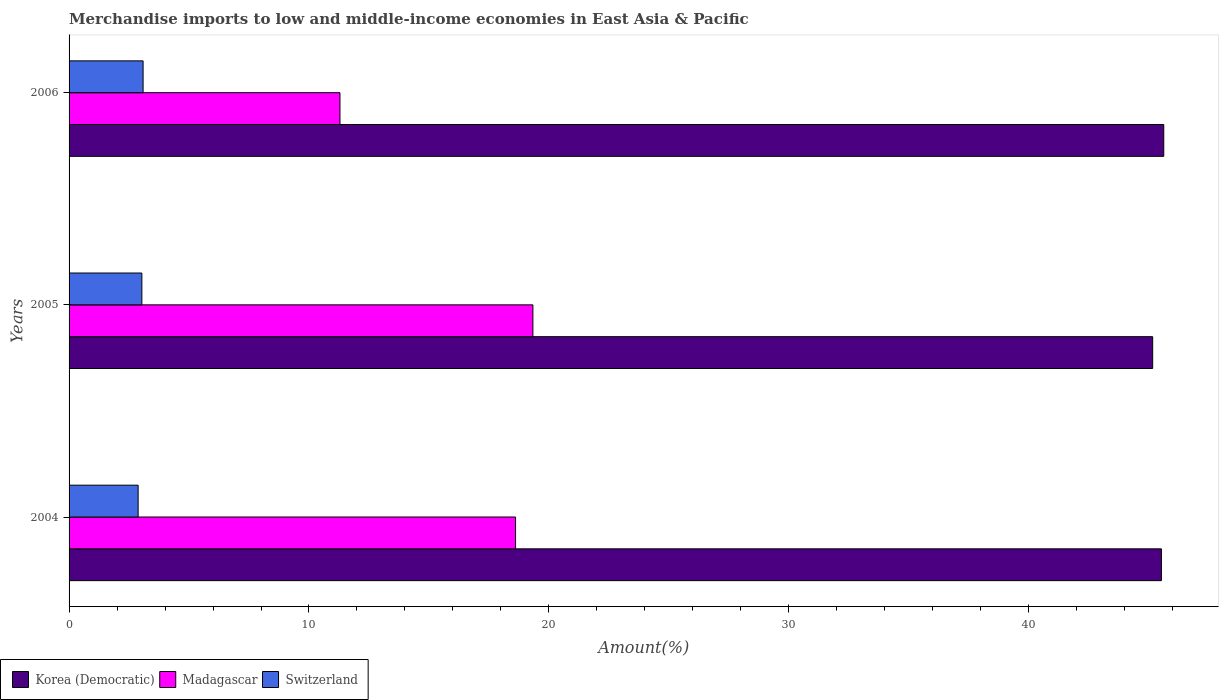How many different coloured bars are there?
Provide a succinct answer. 3. How many groups of bars are there?
Give a very brief answer. 3. Are the number of bars on each tick of the Y-axis equal?
Your answer should be very brief. Yes. How many bars are there on the 2nd tick from the bottom?
Give a very brief answer. 3. In how many cases, is the number of bars for a given year not equal to the number of legend labels?
Offer a terse response. 0. What is the percentage of amount earned from merchandise imports in Switzerland in 2006?
Offer a terse response. 3.09. Across all years, what is the maximum percentage of amount earned from merchandise imports in Switzerland?
Make the answer very short. 3.09. Across all years, what is the minimum percentage of amount earned from merchandise imports in Switzerland?
Give a very brief answer. 2.88. In which year was the percentage of amount earned from merchandise imports in Korea (Democratic) minimum?
Your response must be concise. 2005. What is the total percentage of amount earned from merchandise imports in Switzerland in the graph?
Your answer should be compact. 9. What is the difference between the percentage of amount earned from merchandise imports in Madagascar in 2004 and that in 2005?
Your answer should be very brief. -0.72. What is the difference between the percentage of amount earned from merchandise imports in Madagascar in 2004 and the percentage of amount earned from merchandise imports in Korea (Democratic) in 2005?
Ensure brevity in your answer.  -26.56. What is the average percentage of amount earned from merchandise imports in Madagascar per year?
Your answer should be compact. 16.41. In the year 2004, what is the difference between the percentage of amount earned from merchandise imports in Madagascar and percentage of amount earned from merchandise imports in Korea (Democratic)?
Give a very brief answer. -26.92. What is the ratio of the percentage of amount earned from merchandise imports in Korea (Democratic) in 2004 to that in 2006?
Ensure brevity in your answer.  1. Is the difference between the percentage of amount earned from merchandise imports in Madagascar in 2005 and 2006 greater than the difference between the percentage of amount earned from merchandise imports in Korea (Democratic) in 2005 and 2006?
Provide a succinct answer. Yes. What is the difference between the highest and the second highest percentage of amount earned from merchandise imports in Korea (Democratic)?
Give a very brief answer. 0.1. What is the difference between the highest and the lowest percentage of amount earned from merchandise imports in Switzerland?
Give a very brief answer. 0.21. What does the 2nd bar from the top in 2006 represents?
Provide a succinct answer. Madagascar. What does the 2nd bar from the bottom in 2004 represents?
Make the answer very short. Madagascar. Are all the bars in the graph horizontal?
Provide a succinct answer. Yes. How many years are there in the graph?
Your response must be concise. 3. Does the graph contain any zero values?
Your answer should be very brief. No. Does the graph contain grids?
Offer a terse response. No. How are the legend labels stacked?
Ensure brevity in your answer.  Horizontal. What is the title of the graph?
Your answer should be very brief. Merchandise imports to low and middle-income economies in East Asia & Pacific. Does "Hungary" appear as one of the legend labels in the graph?
Give a very brief answer. No. What is the label or title of the X-axis?
Keep it short and to the point. Amount(%). What is the Amount(%) in Korea (Democratic) in 2004?
Your answer should be compact. 45.53. What is the Amount(%) in Madagascar in 2004?
Your answer should be very brief. 18.61. What is the Amount(%) of Switzerland in 2004?
Provide a succinct answer. 2.88. What is the Amount(%) of Korea (Democratic) in 2005?
Offer a very short reply. 45.17. What is the Amount(%) of Madagascar in 2005?
Offer a very short reply. 19.33. What is the Amount(%) of Switzerland in 2005?
Your answer should be very brief. 3.03. What is the Amount(%) of Korea (Democratic) in 2006?
Make the answer very short. 45.63. What is the Amount(%) in Madagascar in 2006?
Provide a succinct answer. 11.29. What is the Amount(%) of Switzerland in 2006?
Your answer should be compact. 3.09. Across all years, what is the maximum Amount(%) of Korea (Democratic)?
Your answer should be very brief. 45.63. Across all years, what is the maximum Amount(%) of Madagascar?
Make the answer very short. 19.33. Across all years, what is the maximum Amount(%) of Switzerland?
Provide a succinct answer. 3.09. Across all years, what is the minimum Amount(%) of Korea (Democratic)?
Give a very brief answer. 45.17. Across all years, what is the minimum Amount(%) in Madagascar?
Offer a very short reply. 11.29. Across all years, what is the minimum Amount(%) in Switzerland?
Your answer should be very brief. 2.88. What is the total Amount(%) in Korea (Democratic) in the graph?
Make the answer very short. 136.33. What is the total Amount(%) in Madagascar in the graph?
Your response must be concise. 49.24. What is the total Amount(%) in Switzerland in the graph?
Your answer should be compact. 9. What is the difference between the Amount(%) in Korea (Democratic) in 2004 and that in 2005?
Offer a terse response. 0.36. What is the difference between the Amount(%) of Madagascar in 2004 and that in 2005?
Give a very brief answer. -0.72. What is the difference between the Amount(%) of Switzerland in 2004 and that in 2005?
Make the answer very short. -0.16. What is the difference between the Amount(%) of Korea (Democratic) in 2004 and that in 2006?
Your response must be concise. -0.1. What is the difference between the Amount(%) of Madagascar in 2004 and that in 2006?
Give a very brief answer. 7.32. What is the difference between the Amount(%) in Switzerland in 2004 and that in 2006?
Make the answer very short. -0.21. What is the difference between the Amount(%) in Korea (Democratic) in 2005 and that in 2006?
Provide a succinct answer. -0.46. What is the difference between the Amount(%) of Madagascar in 2005 and that in 2006?
Give a very brief answer. 8.04. What is the difference between the Amount(%) of Switzerland in 2005 and that in 2006?
Provide a succinct answer. -0.05. What is the difference between the Amount(%) of Korea (Democratic) in 2004 and the Amount(%) of Madagascar in 2005?
Your response must be concise. 26.2. What is the difference between the Amount(%) of Korea (Democratic) in 2004 and the Amount(%) of Switzerland in 2005?
Ensure brevity in your answer.  42.5. What is the difference between the Amount(%) of Madagascar in 2004 and the Amount(%) of Switzerland in 2005?
Make the answer very short. 15.58. What is the difference between the Amount(%) in Korea (Democratic) in 2004 and the Amount(%) in Madagascar in 2006?
Your answer should be very brief. 34.24. What is the difference between the Amount(%) of Korea (Democratic) in 2004 and the Amount(%) of Switzerland in 2006?
Your answer should be very brief. 42.45. What is the difference between the Amount(%) in Madagascar in 2004 and the Amount(%) in Switzerland in 2006?
Offer a terse response. 15.53. What is the difference between the Amount(%) in Korea (Democratic) in 2005 and the Amount(%) in Madagascar in 2006?
Offer a terse response. 33.88. What is the difference between the Amount(%) in Korea (Democratic) in 2005 and the Amount(%) in Switzerland in 2006?
Your response must be concise. 42.08. What is the difference between the Amount(%) of Madagascar in 2005 and the Amount(%) of Switzerland in 2006?
Make the answer very short. 16.25. What is the average Amount(%) in Korea (Democratic) per year?
Offer a terse response. 45.44. What is the average Amount(%) of Madagascar per year?
Ensure brevity in your answer.  16.41. What is the average Amount(%) in Switzerland per year?
Keep it short and to the point. 3. In the year 2004, what is the difference between the Amount(%) in Korea (Democratic) and Amount(%) in Madagascar?
Make the answer very short. 26.92. In the year 2004, what is the difference between the Amount(%) in Korea (Democratic) and Amount(%) in Switzerland?
Make the answer very short. 42.65. In the year 2004, what is the difference between the Amount(%) in Madagascar and Amount(%) in Switzerland?
Provide a short and direct response. 15.73. In the year 2005, what is the difference between the Amount(%) of Korea (Democratic) and Amount(%) of Madagascar?
Your answer should be compact. 25.83. In the year 2005, what is the difference between the Amount(%) in Korea (Democratic) and Amount(%) in Switzerland?
Provide a succinct answer. 42.13. In the year 2005, what is the difference between the Amount(%) of Madagascar and Amount(%) of Switzerland?
Give a very brief answer. 16.3. In the year 2006, what is the difference between the Amount(%) of Korea (Democratic) and Amount(%) of Madagascar?
Your answer should be compact. 34.34. In the year 2006, what is the difference between the Amount(%) in Korea (Democratic) and Amount(%) in Switzerland?
Offer a very short reply. 42.54. In the year 2006, what is the difference between the Amount(%) of Madagascar and Amount(%) of Switzerland?
Your answer should be very brief. 8.21. What is the ratio of the Amount(%) of Madagascar in 2004 to that in 2005?
Offer a very short reply. 0.96. What is the ratio of the Amount(%) in Switzerland in 2004 to that in 2005?
Make the answer very short. 0.95. What is the ratio of the Amount(%) in Korea (Democratic) in 2004 to that in 2006?
Your response must be concise. 1. What is the ratio of the Amount(%) in Madagascar in 2004 to that in 2006?
Offer a very short reply. 1.65. What is the ratio of the Amount(%) of Switzerland in 2004 to that in 2006?
Your answer should be compact. 0.93. What is the ratio of the Amount(%) of Madagascar in 2005 to that in 2006?
Your answer should be very brief. 1.71. What is the ratio of the Amount(%) of Switzerland in 2005 to that in 2006?
Your response must be concise. 0.98. What is the difference between the highest and the second highest Amount(%) in Korea (Democratic)?
Keep it short and to the point. 0.1. What is the difference between the highest and the second highest Amount(%) in Madagascar?
Offer a very short reply. 0.72. What is the difference between the highest and the second highest Amount(%) in Switzerland?
Make the answer very short. 0.05. What is the difference between the highest and the lowest Amount(%) of Korea (Democratic)?
Provide a succinct answer. 0.46. What is the difference between the highest and the lowest Amount(%) in Madagascar?
Offer a terse response. 8.04. What is the difference between the highest and the lowest Amount(%) in Switzerland?
Offer a very short reply. 0.21. 